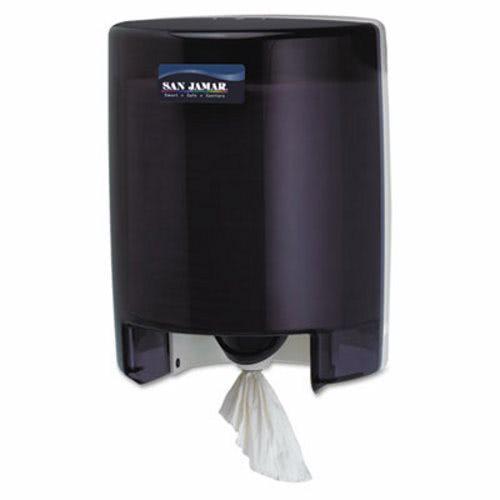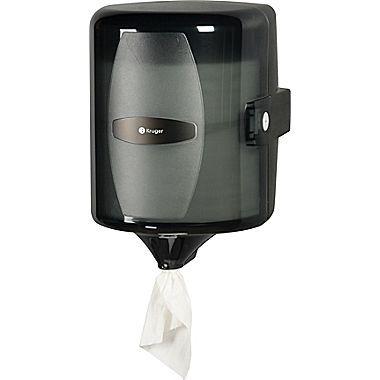The first image is the image on the left, the second image is the image on the right. Examine the images to the left and right. Is the description "The image on the right shows a person reaching for a disposable paper towel." accurate? Answer yes or no. No. The first image is the image on the left, the second image is the image on the right. Analyze the images presented: Is the assertion "In one of the image there are two paper rolls next to a paper towel dispenser." valid? Answer yes or no. No. 